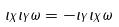Convert formula to latex. <formula><loc_0><loc_0><loc_500><loc_500>\iota _ { X } \iota _ { Y } \omega = - \iota _ { Y } \iota _ { X } \omega</formula> 